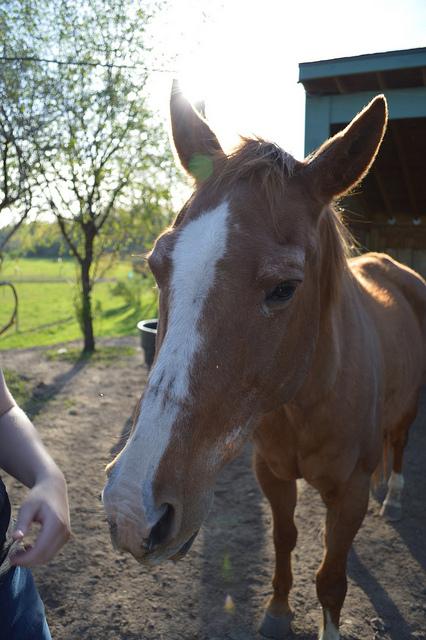Is the horse's face relatively symmetrical?
Answer briefly. Yes. What kind of animal is this?
Write a very short answer. Horse. What type of animal is this?
Concise answer only. Horse. Does the horse have white on it's face?
Short answer required. Yes. Is this a wild animal?
Answer briefly. No. 